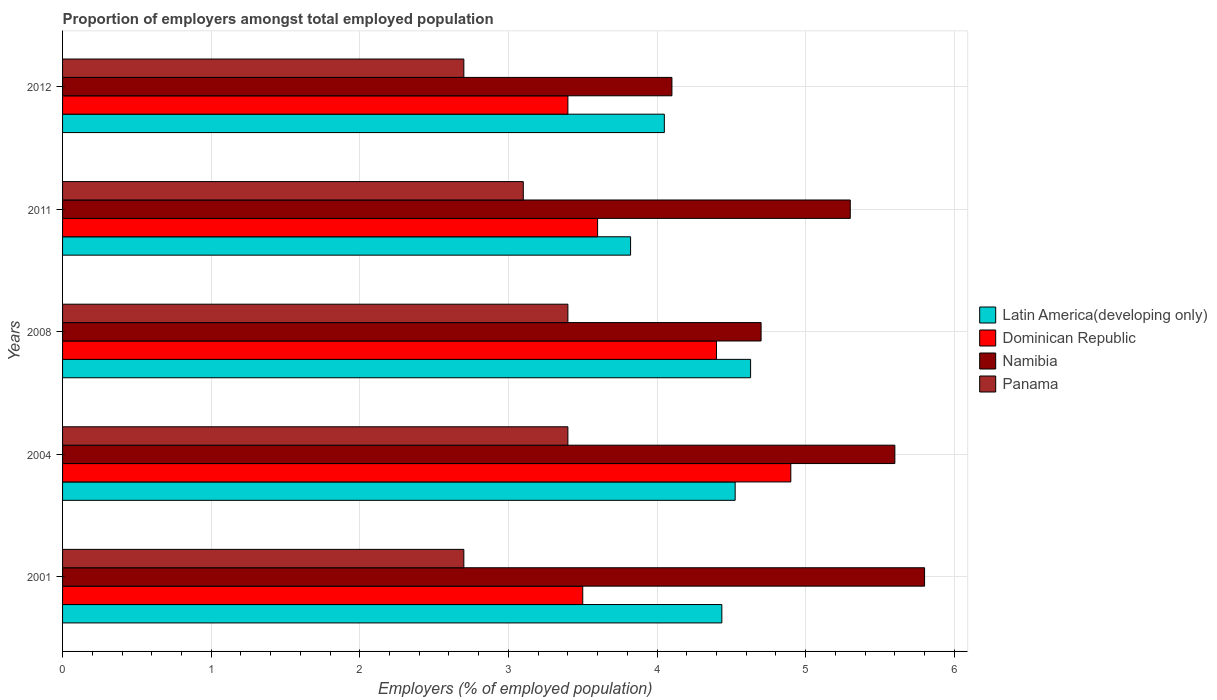How many different coloured bars are there?
Offer a very short reply. 4. Are the number of bars per tick equal to the number of legend labels?
Offer a very short reply. Yes. How many bars are there on the 2nd tick from the bottom?
Give a very brief answer. 4. In how many cases, is the number of bars for a given year not equal to the number of legend labels?
Offer a terse response. 0. What is the proportion of employers in Panama in 2011?
Provide a succinct answer. 3.1. Across all years, what is the maximum proportion of employers in Namibia?
Your response must be concise. 5.8. Across all years, what is the minimum proportion of employers in Panama?
Keep it short and to the point. 2.7. In which year was the proportion of employers in Dominican Republic maximum?
Your response must be concise. 2004. In which year was the proportion of employers in Dominican Republic minimum?
Your response must be concise. 2012. What is the total proportion of employers in Latin America(developing only) in the graph?
Provide a short and direct response. 21.46. What is the difference between the proportion of employers in Namibia in 2004 and that in 2012?
Make the answer very short. 1.5. What is the difference between the proportion of employers in Latin America(developing only) in 2011 and the proportion of employers in Panama in 2001?
Your answer should be very brief. 1.12. What is the average proportion of employers in Dominican Republic per year?
Your answer should be very brief. 3.96. In the year 2012, what is the difference between the proportion of employers in Panama and proportion of employers in Latin America(developing only)?
Provide a succinct answer. -1.35. In how many years, is the proportion of employers in Panama greater than 1.4 %?
Provide a short and direct response. 5. What is the ratio of the proportion of employers in Latin America(developing only) in 2001 to that in 2004?
Your answer should be very brief. 0.98. Is the difference between the proportion of employers in Panama in 2004 and 2011 greater than the difference between the proportion of employers in Latin America(developing only) in 2004 and 2011?
Provide a short and direct response. No. What is the difference between the highest and the second highest proportion of employers in Namibia?
Provide a short and direct response. 0.2. What is the difference between the highest and the lowest proportion of employers in Namibia?
Keep it short and to the point. 1.7. Is it the case that in every year, the sum of the proportion of employers in Namibia and proportion of employers in Panama is greater than the sum of proportion of employers in Latin America(developing only) and proportion of employers in Dominican Republic?
Offer a very short reply. No. What does the 2nd bar from the top in 2004 represents?
Provide a succinct answer. Namibia. What does the 3rd bar from the bottom in 2008 represents?
Offer a terse response. Namibia. Is it the case that in every year, the sum of the proportion of employers in Namibia and proportion of employers in Dominican Republic is greater than the proportion of employers in Panama?
Offer a very short reply. Yes. How many bars are there?
Offer a terse response. 20. How many years are there in the graph?
Provide a short and direct response. 5. What is the difference between two consecutive major ticks on the X-axis?
Offer a very short reply. 1. Does the graph contain any zero values?
Ensure brevity in your answer.  No. Does the graph contain grids?
Your response must be concise. Yes. Where does the legend appear in the graph?
Your response must be concise. Center right. How many legend labels are there?
Offer a terse response. 4. How are the legend labels stacked?
Make the answer very short. Vertical. What is the title of the graph?
Ensure brevity in your answer.  Proportion of employers amongst total employed population. Does "Barbados" appear as one of the legend labels in the graph?
Provide a short and direct response. No. What is the label or title of the X-axis?
Provide a succinct answer. Employers (% of employed population). What is the label or title of the Y-axis?
Give a very brief answer. Years. What is the Employers (% of employed population) in Latin America(developing only) in 2001?
Provide a succinct answer. 4.44. What is the Employers (% of employed population) in Namibia in 2001?
Offer a terse response. 5.8. What is the Employers (% of employed population) of Panama in 2001?
Your answer should be compact. 2.7. What is the Employers (% of employed population) in Latin America(developing only) in 2004?
Ensure brevity in your answer.  4.53. What is the Employers (% of employed population) of Dominican Republic in 2004?
Offer a terse response. 4.9. What is the Employers (% of employed population) in Namibia in 2004?
Ensure brevity in your answer.  5.6. What is the Employers (% of employed population) of Panama in 2004?
Keep it short and to the point. 3.4. What is the Employers (% of employed population) in Latin America(developing only) in 2008?
Your response must be concise. 4.63. What is the Employers (% of employed population) of Dominican Republic in 2008?
Give a very brief answer. 4.4. What is the Employers (% of employed population) of Namibia in 2008?
Offer a very short reply. 4.7. What is the Employers (% of employed population) in Panama in 2008?
Keep it short and to the point. 3.4. What is the Employers (% of employed population) of Latin America(developing only) in 2011?
Your answer should be compact. 3.82. What is the Employers (% of employed population) of Dominican Republic in 2011?
Give a very brief answer. 3.6. What is the Employers (% of employed population) in Namibia in 2011?
Ensure brevity in your answer.  5.3. What is the Employers (% of employed population) in Panama in 2011?
Offer a terse response. 3.1. What is the Employers (% of employed population) of Latin America(developing only) in 2012?
Provide a short and direct response. 4.05. What is the Employers (% of employed population) of Dominican Republic in 2012?
Offer a very short reply. 3.4. What is the Employers (% of employed population) of Namibia in 2012?
Provide a succinct answer. 4.1. What is the Employers (% of employed population) of Panama in 2012?
Make the answer very short. 2.7. Across all years, what is the maximum Employers (% of employed population) in Latin America(developing only)?
Provide a succinct answer. 4.63. Across all years, what is the maximum Employers (% of employed population) of Dominican Republic?
Your answer should be very brief. 4.9. Across all years, what is the maximum Employers (% of employed population) of Namibia?
Give a very brief answer. 5.8. Across all years, what is the maximum Employers (% of employed population) of Panama?
Offer a terse response. 3.4. Across all years, what is the minimum Employers (% of employed population) of Latin America(developing only)?
Ensure brevity in your answer.  3.82. Across all years, what is the minimum Employers (% of employed population) of Dominican Republic?
Offer a very short reply. 3.4. Across all years, what is the minimum Employers (% of employed population) of Namibia?
Make the answer very short. 4.1. Across all years, what is the minimum Employers (% of employed population) of Panama?
Ensure brevity in your answer.  2.7. What is the total Employers (% of employed population) of Latin America(developing only) in the graph?
Offer a terse response. 21.46. What is the total Employers (% of employed population) of Dominican Republic in the graph?
Offer a very short reply. 19.8. What is the total Employers (% of employed population) of Namibia in the graph?
Provide a succinct answer. 25.5. What is the difference between the Employers (% of employed population) in Latin America(developing only) in 2001 and that in 2004?
Your answer should be very brief. -0.09. What is the difference between the Employers (% of employed population) of Dominican Republic in 2001 and that in 2004?
Provide a succinct answer. -1.4. What is the difference between the Employers (% of employed population) in Namibia in 2001 and that in 2004?
Your response must be concise. 0.2. What is the difference between the Employers (% of employed population) of Latin America(developing only) in 2001 and that in 2008?
Offer a terse response. -0.19. What is the difference between the Employers (% of employed population) of Latin America(developing only) in 2001 and that in 2011?
Provide a succinct answer. 0.61. What is the difference between the Employers (% of employed population) in Dominican Republic in 2001 and that in 2011?
Provide a short and direct response. -0.1. What is the difference between the Employers (% of employed population) in Namibia in 2001 and that in 2011?
Your answer should be compact. 0.5. What is the difference between the Employers (% of employed population) of Latin America(developing only) in 2001 and that in 2012?
Offer a very short reply. 0.39. What is the difference between the Employers (% of employed population) in Namibia in 2001 and that in 2012?
Ensure brevity in your answer.  1.7. What is the difference between the Employers (% of employed population) in Latin America(developing only) in 2004 and that in 2008?
Your answer should be very brief. -0.1. What is the difference between the Employers (% of employed population) in Dominican Republic in 2004 and that in 2008?
Your answer should be compact. 0.5. What is the difference between the Employers (% of employed population) in Namibia in 2004 and that in 2008?
Give a very brief answer. 0.9. What is the difference between the Employers (% of employed population) of Panama in 2004 and that in 2008?
Give a very brief answer. 0. What is the difference between the Employers (% of employed population) of Latin America(developing only) in 2004 and that in 2011?
Provide a short and direct response. 0.7. What is the difference between the Employers (% of employed population) of Dominican Republic in 2004 and that in 2011?
Ensure brevity in your answer.  1.3. What is the difference between the Employers (% of employed population) in Namibia in 2004 and that in 2011?
Provide a succinct answer. 0.3. What is the difference between the Employers (% of employed population) in Panama in 2004 and that in 2011?
Your answer should be compact. 0.3. What is the difference between the Employers (% of employed population) in Latin America(developing only) in 2004 and that in 2012?
Ensure brevity in your answer.  0.48. What is the difference between the Employers (% of employed population) in Panama in 2004 and that in 2012?
Your answer should be compact. 0.7. What is the difference between the Employers (% of employed population) in Latin America(developing only) in 2008 and that in 2011?
Make the answer very short. 0.81. What is the difference between the Employers (% of employed population) in Dominican Republic in 2008 and that in 2011?
Your response must be concise. 0.8. What is the difference between the Employers (% of employed population) of Namibia in 2008 and that in 2011?
Offer a very short reply. -0.6. What is the difference between the Employers (% of employed population) of Panama in 2008 and that in 2011?
Offer a terse response. 0.3. What is the difference between the Employers (% of employed population) of Latin America(developing only) in 2008 and that in 2012?
Your answer should be compact. 0.58. What is the difference between the Employers (% of employed population) in Panama in 2008 and that in 2012?
Your answer should be compact. 0.7. What is the difference between the Employers (% of employed population) in Latin America(developing only) in 2011 and that in 2012?
Keep it short and to the point. -0.23. What is the difference between the Employers (% of employed population) of Namibia in 2011 and that in 2012?
Make the answer very short. 1.2. What is the difference between the Employers (% of employed population) in Latin America(developing only) in 2001 and the Employers (% of employed population) in Dominican Republic in 2004?
Make the answer very short. -0.46. What is the difference between the Employers (% of employed population) in Latin America(developing only) in 2001 and the Employers (% of employed population) in Namibia in 2004?
Your answer should be very brief. -1.16. What is the difference between the Employers (% of employed population) of Latin America(developing only) in 2001 and the Employers (% of employed population) of Panama in 2004?
Give a very brief answer. 1.04. What is the difference between the Employers (% of employed population) in Dominican Republic in 2001 and the Employers (% of employed population) in Namibia in 2004?
Ensure brevity in your answer.  -2.1. What is the difference between the Employers (% of employed population) in Dominican Republic in 2001 and the Employers (% of employed population) in Panama in 2004?
Give a very brief answer. 0.1. What is the difference between the Employers (% of employed population) in Namibia in 2001 and the Employers (% of employed population) in Panama in 2004?
Your response must be concise. 2.4. What is the difference between the Employers (% of employed population) in Latin America(developing only) in 2001 and the Employers (% of employed population) in Dominican Republic in 2008?
Give a very brief answer. 0.04. What is the difference between the Employers (% of employed population) of Latin America(developing only) in 2001 and the Employers (% of employed population) of Namibia in 2008?
Your response must be concise. -0.26. What is the difference between the Employers (% of employed population) of Latin America(developing only) in 2001 and the Employers (% of employed population) of Panama in 2008?
Ensure brevity in your answer.  1.04. What is the difference between the Employers (% of employed population) of Latin America(developing only) in 2001 and the Employers (% of employed population) of Dominican Republic in 2011?
Keep it short and to the point. 0.84. What is the difference between the Employers (% of employed population) in Latin America(developing only) in 2001 and the Employers (% of employed population) in Namibia in 2011?
Offer a terse response. -0.86. What is the difference between the Employers (% of employed population) of Latin America(developing only) in 2001 and the Employers (% of employed population) of Panama in 2011?
Your answer should be very brief. 1.34. What is the difference between the Employers (% of employed population) in Dominican Republic in 2001 and the Employers (% of employed population) in Namibia in 2011?
Provide a succinct answer. -1.8. What is the difference between the Employers (% of employed population) in Latin America(developing only) in 2001 and the Employers (% of employed population) in Dominican Republic in 2012?
Offer a very short reply. 1.04. What is the difference between the Employers (% of employed population) in Latin America(developing only) in 2001 and the Employers (% of employed population) in Namibia in 2012?
Provide a succinct answer. 0.34. What is the difference between the Employers (% of employed population) in Latin America(developing only) in 2001 and the Employers (% of employed population) in Panama in 2012?
Provide a short and direct response. 1.74. What is the difference between the Employers (% of employed population) in Dominican Republic in 2001 and the Employers (% of employed population) in Namibia in 2012?
Make the answer very short. -0.6. What is the difference between the Employers (% of employed population) of Dominican Republic in 2001 and the Employers (% of employed population) of Panama in 2012?
Provide a succinct answer. 0.8. What is the difference between the Employers (% of employed population) of Latin America(developing only) in 2004 and the Employers (% of employed population) of Dominican Republic in 2008?
Keep it short and to the point. 0.13. What is the difference between the Employers (% of employed population) in Latin America(developing only) in 2004 and the Employers (% of employed population) in Namibia in 2008?
Ensure brevity in your answer.  -0.17. What is the difference between the Employers (% of employed population) in Latin America(developing only) in 2004 and the Employers (% of employed population) in Panama in 2008?
Your answer should be compact. 1.13. What is the difference between the Employers (% of employed population) of Dominican Republic in 2004 and the Employers (% of employed population) of Namibia in 2008?
Provide a succinct answer. 0.2. What is the difference between the Employers (% of employed population) in Dominican Republic in 2004 and the Employers (% of employed population) in Panama in 2008?
Make the answer very short. 1.5. What is the difference between the Employers (% of employed population) in Latin America(developing only) in 2004 and the Employers (% of employed population) in Dominican Republic in 2011?
Provide a short and direct response. 0.93. What is the difference between the Employers (% of employed population) in Latin America(developing only) in 2004 and the Employers (% of employed population) in Namibia in 2011?
Give a very brief answer. -0.77. What is the difference between the Employers (% of employed population) of Latin America(developing only) in 2004 and the Employers (% of employed population) of Panama in 2011?
Your response must be concise. 1.43. What is the difference between the Employers (% of employed population) in Dominican Republic in 2004 and the Employers (% of employed population) in Namibia in 2011?
Provide a succinct answer. -0.4. What is the difference between the Employers (% of employed population) of Dominican Republic in 2004 and the Employers (% of employed population) of Panama in 2011?
Give a very brief answer. 1.8. What is the difference between the Employers (% of employed population) of Namibia in 2004 and the Employers (% of employed population) of Panama in 2011?
Offer a very short reply. 2.5. What is the difference between the Employers (% of employed population) of Latin America(developing only) in 2004 and the Employers (% of employed population) of Dominican Republic in 2012?
Your response must be concise. 1.13. What is the difference between the Employers (% of employed population) in Latin America(developing only) in 2004 and the Employers (% of employed population) in Namibia in 2012?
Offer a terse response. 0.43. What is the difference between the Employers (% of employed population) of Latin America(developing only) in 2004 and the Employers (% of employed population) of Panama in 2012?
Ensure brevity in your answer.  1.83. What is the difference between the Employers (% of employed population) of Dominican Republic in 2004 and the Employers (% of employed population) of Panama in 2012?
Ensure brevity in your answer.  2.2. What is the difference between the Employers (% of employed population) in Namibia in 2004 and the Employers (% of employed population) in Panama in 2012?
Keep it short and to the point. 2.9. What is the difference between the Employers (% of employed population) in Latin America(developing only) in 2008 and the Employers (% of employed population) in Dominican Republic in 2011?
Give a very brief answer. 1.03. What is the difference between the Employers (% of employed population) of Latin America(developing only) in 2008 and the Employers (% of employed population) of Namibia in 2011?
Make the answer very short. -0.67. What is the difference between the Employers (% of employed population) of Latin America(developing only) in 2008 and the Employers (% of employed population) of Panama in 2011?
Provide a succinct answer. 1.53. What is the difference between the Employers (% of employed population) in Dominican Republic in 2008 and the Employers (% of employed population) in Panama in 2011?
Keep it short and to the point. 1.3. What is the difference between the Employers (% of employed population) of Latin America(developing only) in 2008 and the Employers (% of employed population) of Dominican Republic in 2012?
Give a very brief answer. 1.23. What is the difference between the Employers (% of employed population) in Latin America(developing only) in 2008 and the Employers (% of employed population) in Namibia in 2012?
Keep it short and to the point. 0.53. What is the difference between the Employers (% of employed population) in Latin America(developing only) in 2008 and the Employers (% of employed population) in Panama in 2012?
Provide a short and direct response. 1.93. What is the difference between the Employers (% of employed population) in Dominican Republic in 2008 and the Employers (% of employed population) in Panama in 2012?
Offer a very short reply. 1.7. What is the difference between the Employers (% of employed population) in Latin America(developing only) in 2011 and the Employers (% of employed population) in Dominican Republic in 2012?
Your answer should be compact. 0.42. What is the difference between the Employers (% of employed population) of Latin America(developing only) in 2011 and the Employers (% of employed population) of Namibia in 2012?
Offer a very short reply. -0.28. What is the difference between the Employers (% of employed population) of Latin America(developing only) in 2011 and the Employers (% of employed population) of Panama in 2012?
Offer a terse response. 1.12. What is the difference between the Employers (% of employed population) of Dominican Republic in 2011 and the Employers (% of employed population) of Panama in 2012?
Ensure brevity in your answer.  0.9. What is the average Employers (% of employed population) of Latin America(developing only) per year?
Ensure brevity in your answer.  4.29. What is the average Employers (% of employed population) in Dominican Republic per year?
Give a very brief answer. 3.96. What is the average Employers (% of employed population) in Namibia per year?
Offer a very short reply. 5.1. What is the average Employers (% of employed population) in Panama per year?
Give a very brief answer. 3.06. In the year 2001, what is the difference between the Employers (% of employed population) in Latin America(developing only) and Employers (% of employed population) in Dominican Republic?
Your answer should be compact. 0.94. In the year 2001, what is the difference between the Employers (% of employed population) in Latin America(developing only) and Employers (% of employed population) in Namibia?
Provide a succinct answer. -1.36. In the year 2001, what is the difference between the Employers (% of employed population) of Latin America(developing only) and Employers (% of employed population) of Panama?
Provide a short and direct response. 1.74. In the year 2001, what is the difference between the Employers (% of employed population) of Dominican Republic and Employers (% of employed population) of Namibia?
Provide a succinct answer. -2.3. In the year 2004, what is the difference between the Employers (% of employed population) in Latin America(developing only) and Employers (% of employed population) in Dominican Republic?
Your answer should be compact. -0.37. In the year 2004, what is the difference between the Employers (% of employed population) in Latin America(developing only) and Employers (% of employed population) in Namibia?
Offer a very short reply. -1.07. In the year 2004, what is the difference between the Employers (% of employed population) in Latin America(developing only) and Employers (% of employed population) in Panama?
Your answer should be compact. 1.13. In the year 2004, what is the difference between the Employers (% of employed population) in Dominican Republic and Employers (% of employed population) in Panama?
Ensure brevity in your answer.  1.5. In the year 2004, what is the difference between the Employers (% of employed population) in Namibia and Employers (% of employed population) in Panama?
Offer a terse response. 2.2. In the year 2008, what is the difference between the Employers (% of employed population) in Latin America(developing only) and Employers (% of employed population) in Dominican Republic?
Give a very brief answer. 0.23. In the year 2008, what is the difference between the Employers (% of employed population) in Latin America(developing only) and Employers (% of employed population) in Namibia?
Make the answer very short. -0.07. In the year 2008, what is the difference between the Employers (% of employed population) in Latin America(developing only) and Employers (% of employed population) in Panama?
Your response must be concise. 1.23. In the year 2008, what is the difference between the Employers (% of employed population) in Namibia and Employers (% of employed population) in Panama?
Ensure brevity in your answer.  1.3. In the year 2011, what is the difference between the Employers (% of employed population) in Latin America(developing only) and Employers (% of employed population) in Dominican Republic?
Provide a short and direct response. 0.22. In the year 2011, what is the difference between the Employers (% of employed population) in Latin America(developing only) and Employers (% of employed population) in Namibia?
Make the answer very short. -1.48. In the year 2011, what is the difference between the Employers (% of employed population) in Latin America(developing only) and Employers (% of employed population) in Panama?
Provide a succinct answer. 0.72. In the year 2011, what is the difference between the Employers (% of employed population) in Dominican Republic and Employers (% of employed population) in Namibia?
Provide a succinct answer. -1.7. In the year 2012, what is the difference between the Employers (% of employed population) of Latin America(developing only) and Employers (% of employed population) of Dominican Republic?
Provide a succinct answer. 0.65. In the year 2012, what is the difference between the Employers (% of employed population) in Latin America(developing only) and Employers (% of employed population) in Namibia?
Make the answer very short. -0.05. In the year 2012, what is the difference between the Employers (% of employed population) in Latin America(developing only) and Employers (% of employed population) in Panama?
Your answer should be compact. 1.35. In the year 2012, what is the difference between the Employers (% of employed population) in Namibia and Employers (% of employed population) in Panama?
Keep it short and to the point. 1.4. What is the ratio of the Employers (% of employed population) of Latin America(developing only) in 2001 to that in 2004?
Your answer should be very brief. 0.98. What is the ratio of the Employers (% of employed population) in Namibia in 2001 to that in 2004?
Make the answer very short. 1.04. What is the ratio of the Employers (% of employed population) of Panama in 2001 to that in 2004?
Ensure brevity in your answer.  0.79. What is the ratio of the Employers (% of employed population) in Latin America(developing only) in 2001 to that in 2008?
Make the answer very short. 0.96. What is the ratio of the Employers (% of employed population) of Dominican Republic in 2001 to that in 2008?
Your answer should be very brief. 0.8. What is the ratio of the Employers (% of employed population) in Namibia in 2001 to that in 2008?
Your answer should be very brief. 1.23. What is the ratio of the Employers (% of employed population) in Panama in 2001 to that in 2008?
Ensure brevity in your answer.  0.79. What is the ratio of the Employers (% of employed population) in Latin America(developing only) in 2001 to that in 2011?
Give a very brief answer. 1.16. What is the ratio of the Employers (% of employed population) of Dominican Republic in 2001 to that in 2011?
Keep it short and to the point. 0.97. What is the ratio of the Employers (% of employed population) of Namibia in 2001 to that in 2011?
Your answer should be very brief. 1.09. What is the ratio of the Employers (% of employed population) of Panama in 2001 to that in 2011?
Provide a short and direct response. 0.87. What is the ratio of the Employers (% of employed population) in Latin America(developing only) in 2001 to that in 2012?
Your answer should be very brief. 1.1. What is the ratio of the Employers (% of employed population) in Dominican Republic in 2001 to that in 2012?
Keep it short and to the point. 1.03. What is the ratio of the Employers (% of employed population) of Namibia in 2001 to that in 2012?
Ensure brevity in your answer.  1.41. What is the ratio of the Employers (% of employed population) of Panama in 2001 to that in 2012?
Your response must be concise. 1. What is the ratio of the Employers (% of employed population) of Latin America(developing only) in 2004 to that in 2008?
Offer a terse response. 0.98. What is the ratio of the Employers (% of employed population) of Dominican Republic in 2004 to that in 2008?
Your answer should be very brief. 1.11. What is the ratio of the Employers (% of employed population) in Namibia in 2004 to that in 2008?
Your answer should be very brief. 1.19. What is the ratio of the Employers (% of employed population) in Latin America(developing only) in 2004 to that in 2011?
Make the answer very short. 1.18. What is the ratio of the Employers (% of employed population) in Dominican Republic in 2004 to that in 2011?
Provide a short and direct response. 1.36. What is the ratio of the Employers (% of employed population) of Namibia in 2004 to that in 2011?
Provide a succinct answer. 1.06. What is the ratio of the Employers (% of employed population) in Panama in 2004 to that in 2011?
Provide a short and direct response. 1.1. What is the ratio of the Employers (% of employed population) of Latin America(developing only) in 2004 to that in 2012?
Your response must be concise. 1.12. What is the ratio of the Employers (% of employed population) of Dominican Republic in 2004 to that in 2012?
Make the answer very short. 1.44. What is the ratio of the Employers (% of employed population) in Namibia in 2004 to that in 2012?
Keep it short and to the point. 1.37. What is the ratio of the Employers (% of employed population) of Panama in 2004 to that in 2012?
Give a very brief answer. 1.26. What is the ratio of the Employers (% of employed population) in Latin America(developing only) in 2008 to that in 2011?
Keep it short and to the point. 1.21. What is the ratio of the Employers (% of employed population) of Dominican Republic in 2008 to that in 2011?
Ensure brevity in your answer.  1.22. What is the ratio of the Employers (% of employed population) of Namibia in 2008 to that in 2011?
Provide a succinct answer. 0.89. What is the ratio of the Employers (% of employed population) in Panama in 2008 to that in 2011?
Make the answer very short. 1.1. What is the ratio of the Employers (% of employed population) in Latin America(developing only) in 2008 to that in 2012?
Provide a short and direct response. 1.14. What is the ratio of the Employers (% of employed population) in Dominican Republic in 2008 to that in 2012?
Provide a succinct answer. 1.29. What is the ratio of the Employers (% of employed population) in Namibia in 2008 to that in 2012?
Provide a succinct answer. 1.15. What is the ratio of the Employers (% of employed population) of Panama in 2008 to that in 2012?
Offer a terse response. 1.26. What is the ratio of the Employers (% of employed population) of Latin America(developing only) in 2011 to that in 2012?
Keep it short and to the point. 0.94. What is the ratio of the Employers (% of employed population) of Dominican Republic in 2011 to that in 2012?
Offer a very short reply. 1.06. What is the ratio of the Employers (% of employed population) in Namibia in 2011 to that in 2012?
Your answer should be compact. 1.29. What is the ratio of the Employers (% of employed population) in Panama in 2011 to that in 2012?
Offer a terse response. 1.15. What is the difference between the highest and the second highest Employers (% of employed population) in Latin America(developing only)?
Provide a short and direct response. 0.1. What is the difference between the highest and the second highest Employers (% of employed population) in Dominican Republic?
Your answer should be compact. 0.5. What is the difference between the highest and the second highest Employers (% of employed population) of Namibia?
Your answer should be very brief. 0.2. What is the difference between the highest and the second highest Employers (% of employed population) in Panama?
Give a very brief answer. 0. What is the difference between the highest and the lowest Employers (% of employed population) of Latin America(developing only)?
Keep it short and to the point. 0.81. 